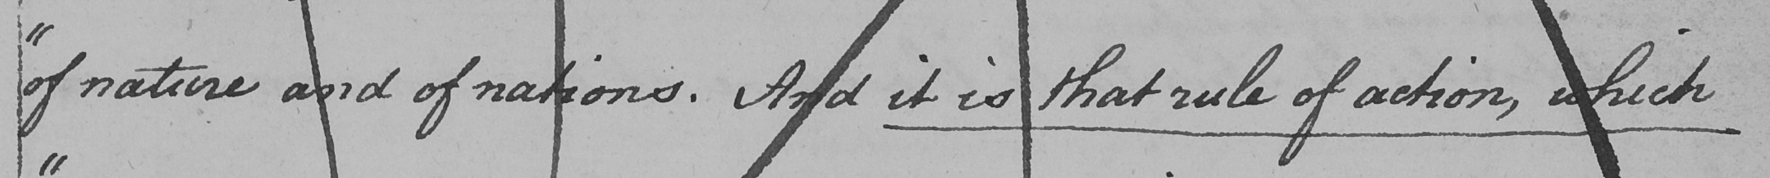Please provide the text content of this handwritten line. " of nature and of nations . And it is that rule of action , which 